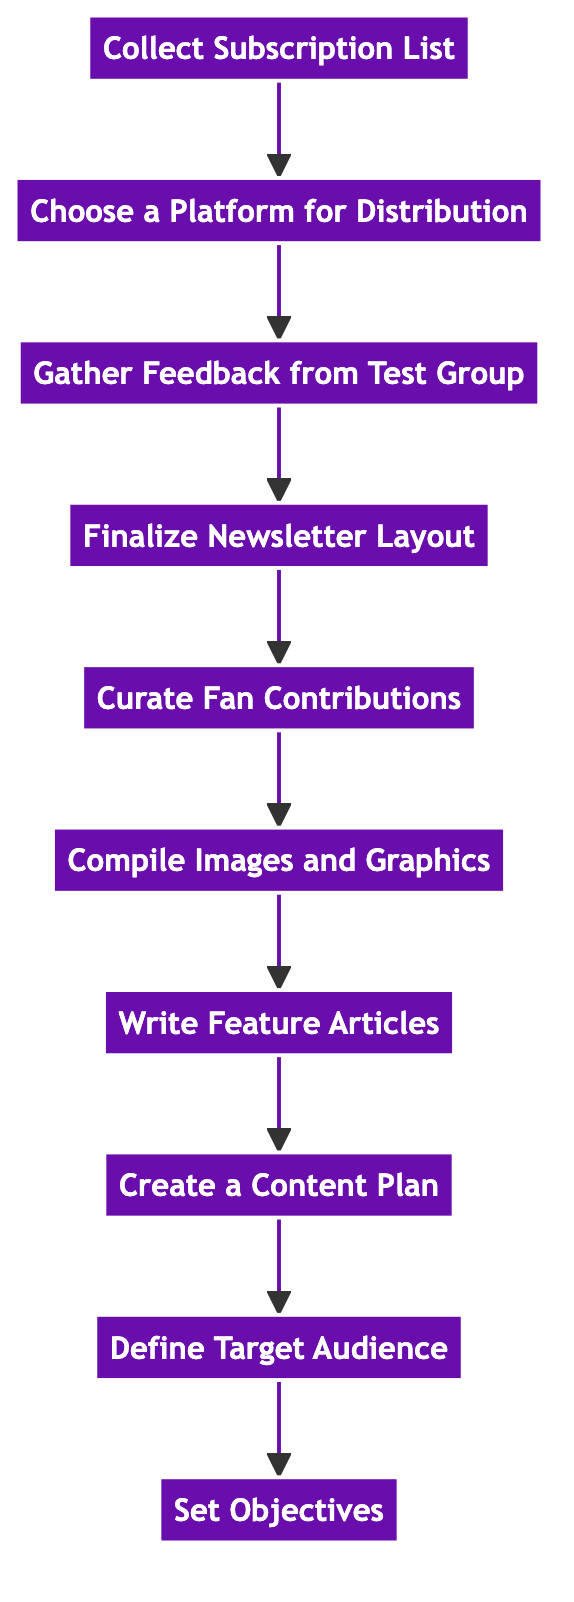What is the first step in the process? The first step in the flowchart is "Set Objectives," as it is located at the bottom of the diagram and serves as the starting point for the instruction flow.
Answer: Set Objectives How many nodes are shown in the diagram? There are ten nodes represented in the diagram, each detailing a specific step in creating and distributing the newsletter.
Answer: 10 Which node comes before "Finalize Newsletter Layout"? The node that comes before "Finalize Newsletter Layout" is "Gather Feedback from Test Group," as it is directly above in the flow sequence.
Answer: Gather Feedback from Test Group What section is immediately after "Curate Fan Contributions"? The section immediately after "Curate Fan Contributions" is "Compile Images and Graphics," as they follow sequentially in the upward flow of the diagram.
Answer: Compile Images and Graphics Which step focuses on collecting input from fans? The step that focuses on collecting input from fans is "Curate Fan Contributions," where fan stories and photographs are included to involve the community.
Answer: Curate Fan Contributions What is the relationship between "Create a Content Plan" and "Write Feature Articles"? "Create a Content Plan" comes before "Write Feature Articles" in the flow, indicating that planning content is a prerequisite for writing the articles.
Answer: Create a Content Plan How is the target audience defined in this process? The target audience is defined in the step "Define Target Audience," where the core segments of supporters are identified before content planning begins.
Answer: Define Target Audience What is the final step in the distribution process? The final step in the distribution process is "Finalize Newsletter Layout," which integrates all sections into the coherent final product of the newsletter.
Answer: Finalize Newsletter Layout Which platform option is suggested for distributing the newsletter? The platform option suggested for distributing the newsletter is found in the node "Choose a Platform for Distribution," where options like Email and Social Media Channels are mentioned.
Answer: Choose a Platform for Distribution What step involves ensuring proper licensing for images? The step that involves ensuring proper licensing for images is "Compile Images and Graphics," where sourcing high-quality images is crucial.
Answer: Compile Images and Graphics 